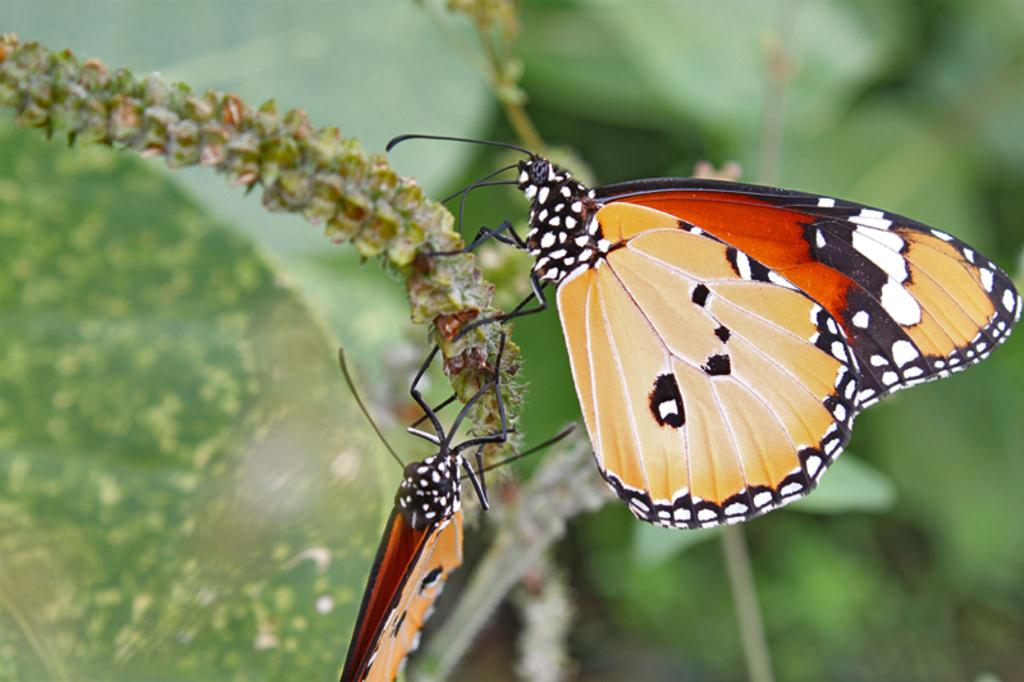What is depicted on the stem in the image? There are butterflies represented on the stem in the image. Are there any other elements present in the image besides the butterflies? There may be leaves present in the image. How does the tiger interact with the butterflies in the image? There is no tiger present in the image, so it cannot interact with the butterflies. 